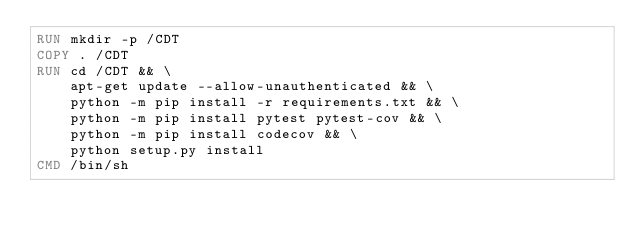<code> <loc_0><loc_0><loc_500><loc_500><_Dockerfile_>RUN mkdir -p /CDT
COPY . /CDT
RUN cd /CDT && \
    apt-get update --allow-unauthenticated && \
    python -m pip install -r requirements.txt && \
    python -m pip install pytest pytest-cov && \
    python -m pip install codecov && \
    python setup.py install
CMD /bin/sh
</code> 